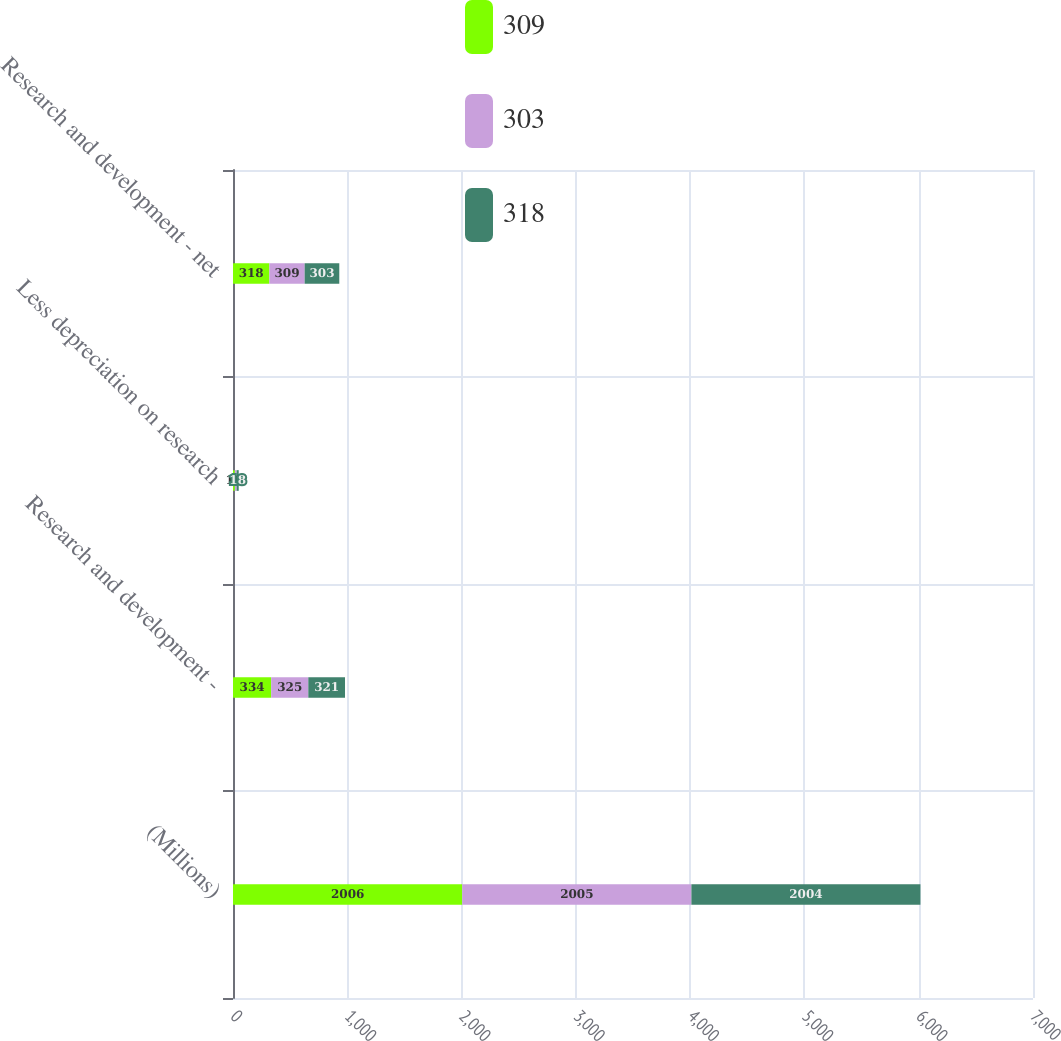Convert chart. <chart><loc_0><loc_0><loc_500><loc_500><stacked_bar_chart><ecel><fcel>(Millions)<fcel>Research and development -<fcel>Less depreciation on research<fcel>Research and development - net<nl><fcel>309<fcel>2006<fcel>334<fcel>16<fcel>318<nl><fcel>303<fcel>2005<fcel>325<fcel>16<fcel>309<nl><fcel>318<fcel>2004<fcel>321<fcel>18<fcel>303<nl></chart> 